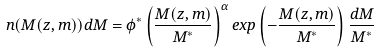Convert formula to latex. <formula><loc_0><loc_0><loc_500><loc_500>n ( M ( z , m ) ) d M = \phi ^ { * } \left ( \frac { M ( z , m ) } { M ^ { * } } \right ) ^ { \alpha } e x p \left ( - \frac { M ( z , m ) } { M ^ { * } } \right ) \frac { d M } { M ^ { * } }</formula> 